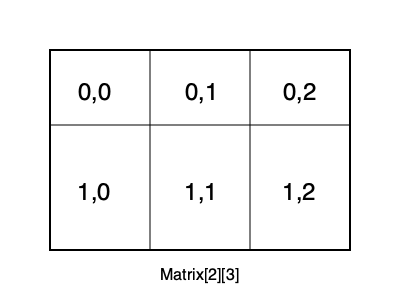In a custom Matrix class representing a 2D grid as shown above, how would you implement the overloaded subscript operator to allow accessing elements using double subscripts, such as `matrix[i][j]`? To implement the overloaded subscript operator for a custom Matrix class allowing double subscripts, follow these steps:

1. Define the Matrix class with member variables for rows, columns, and a 1D array to store elements:
   ```cpp
   class Matrix {
   private:
       int rows, cols;
       double* data;
   public:
       // ... constructor, destructor, other methods ...
   };
   ```

2. Implement a proxy class to handle the second subscript:
   ```cpp
   class RowProxy {
   private:
       double* row;
       int cols;
   public:
       RowProxy(double* r, int c) : row(r), cols(c) {}
       double& operator[](int j) {
           if (j < 0 || j >= cols) throw std::out_of_range("Column index out of range");
           return row[j];
       }
   };
   ```

3. Overload the subscript operator in the Matrix class to return a RowProxy object:
   ```cpp
   RowProxy operator[](int i) {
       if (i < 0 || i >= rows) throw std::out_of_range("Row index out of range");
       return RowProxy(data + i * cols, cols);
   }
   ```

4. Implement const versions of both operators for read-only access:
   ```cpp
   const RowProxy operator[](int i) const {
       if (i < 0 || i >= rows) throw std::out_of_range("Row index out of range");
       return RowProxy(data + i * cols, cols);
   }
   ```
   ```cpp
   // In RowProxy class
   const double& operator[](int j) const {
       if (j < 0 || j >= cols) throw std::out_of_range("Column index out of range");
       return row[j];
   }
   ```

This implementation allows for intuitive element access using `matrix[i][j]`, where `i` is the row index and `j` is the column index, both zero-based.
Answer: Implement a proxy class for row access and overload `operator[]` twice: once in the Matrix class to return the proxy, and once in the proxy class for column access. 